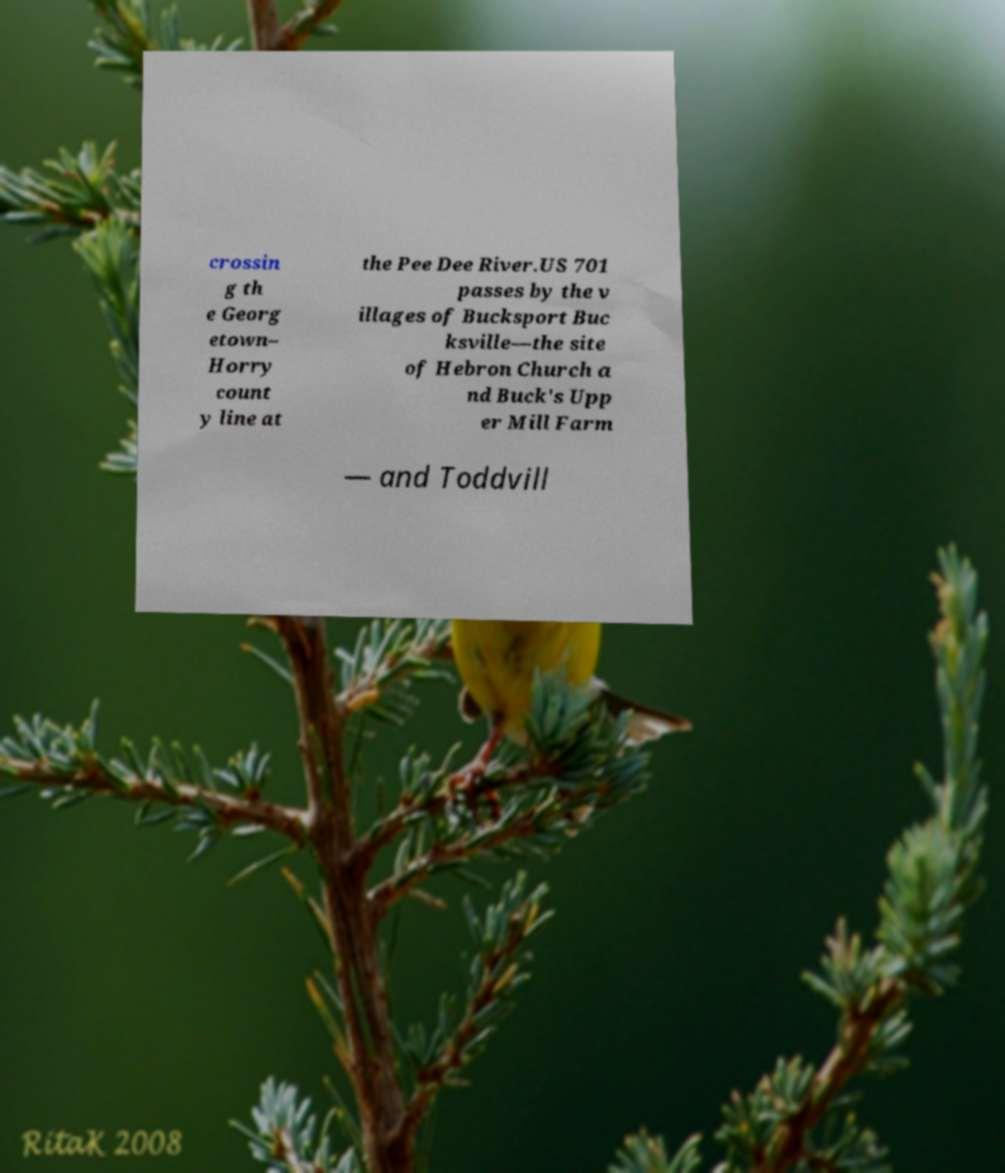Can you accurately transcribe the text from the provided image for me? crossin g th e Georg etown– Horry count y line at the Pee Dee River.US 701 passes by the v illages of Bucksport Buc ksville—the site of Hebron Church a nd Buck's Upp er Mill Farm — and Toddvill 